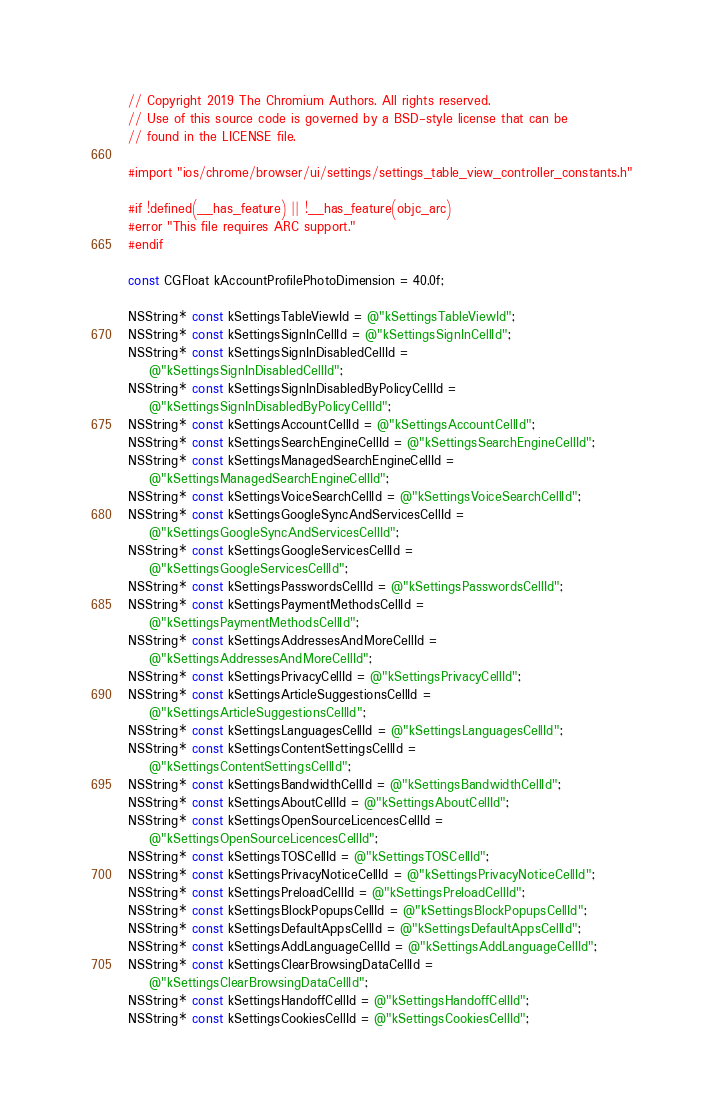<code> <loc_0><loc_0><loc_500><loc_500><_ObjectiveC_>// Copyright 2019 The Chromium Authors. All rights reserved.
// Use of this source code is governed by a BSD-style license that can be
// found in the LICENSE file.

#import "ios/chrome/browser/ui/settings/settings_table_view_controller_constants.h"

#if !defined(__has_feature) || !__has_feature(objc_arc)
#error "This file requires ARC support."
#endif

const CGFloat kAccountProfilePhotoDimension = 40.0f;

NSString* const kSettingsTableViewId = @"kSettingsTableViewId";
NSString* const kSettingsSignInCellId = @"kSettingsSignInCellId";
NSString* const kSettingsSignInDisabledCellId =
    @"kSettingsSignInDisabledCellId";
NSString* const kSettingsSignInDisabledByPolicyCellId =
    @"kSettingsSignInDisabledByPolicyCellId";
NSString* const kSettingsAccountCellId = @"kSettingsAccountCellId";
NSString* const kSettingsSearchEngineCellId = @"kSettingsSearchEngineCellId";
NSString* const kSettingsManagedSearchEngineCellId =
    @"kSettingsManagedSearchEngineCellId";
NSString* const kSettingsVoiceSearchCellId = @"kSettingsVoiceSearchCellId";
NSString* const kSettingsGoogleSyncAndServicesCellId =
    @"kSettingsGoogleSyncAndServicesCellId";
NSString* const kSettingsGoogleServicesCellId =
    @"kSettingsGoogleServicesCellId";
NSString* const kSettingsPasswordsCellId = @"kSettingsPasswordsCellId";
NSString* const kSettingsPaymentMethodsCellId =
    @"kSettingsPaymentMethodsCellId";
NSString* const kSettingsAddressesAndMoreCellId =
    @"kSettingsAddressesAndMoreCellId";
NSString* const kSettingsPrivacyCellId = @"kSettingsPrivacyCellId";
NSString* const kSettingsArticleSuggestionsCellId =
    @"kSettingsArticleSuggestionsCellId";
NSString* const kSettingsLanguagesCellId = @"kSettingsLanguagesCellId";
NSString* const kSettingsContentSettingsCellId =
    @"kSettingsContentSettingsCellId";
NSString* const kSettingsBandwidthCellId = @"kSettingsBandwidthCellId";
NSString* const kSettingsAboutCellId = @"kSettingsAboutCellId";
NSString* const kSettingsOpenSourceLicencesCellId =
    @"kSettingsOpenSourceLicencesCellId";
NSString* const kSettingsTOSCellId = @"kSettingsTOSCellId";
NSString* const kSettingsPrivacyNoticeCellId = @"kSettingsPrivacyNoticeCellId";
NSString* const kSettingsPreloadCellId = @"kSettingsPreloadCellId";
NSString* const kSettingsBlockPopupsCellId = @"kSettingsBlockPopupsCellId";
NSString* const kSettingsDefaultAppsCellId = @"kSettingsDefaultAppsCellId";
NSString* const kSettingsAddLanguageCellId = @"kSettingsAddLanguageCellId";
NSString* const kSettingsClearBrowsingDataCellId =
    @"kSettingsClearBrowsingDataCellId";
NSString* const kSettingsHandoffCellId = @"kSettingsHandoffCellId";
NSString* const kSettingsCookiesCellId = @"kSettingsCookiesCellId";
</code> 